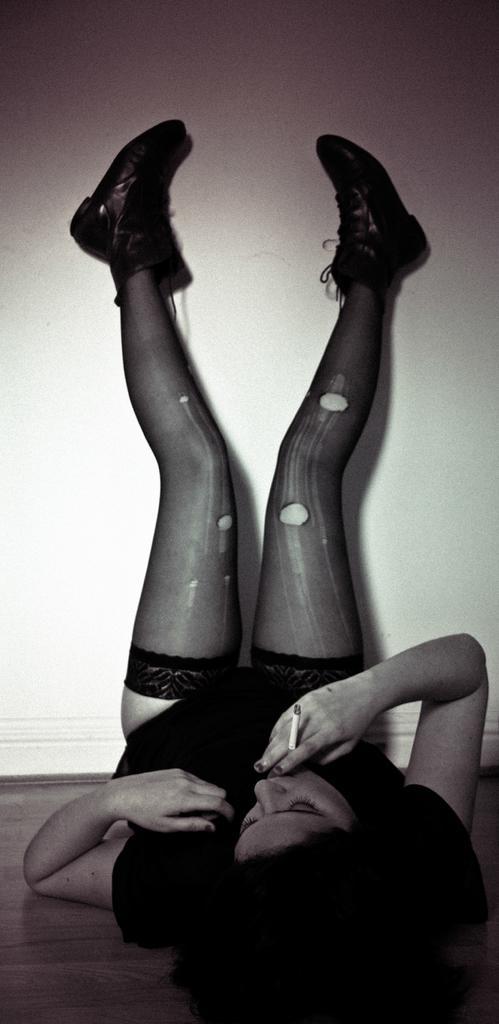Can you describe this image briefly? A black and white picture. This woman is holding a cigar in her fingers. Woman lying on floor with raised legs. 